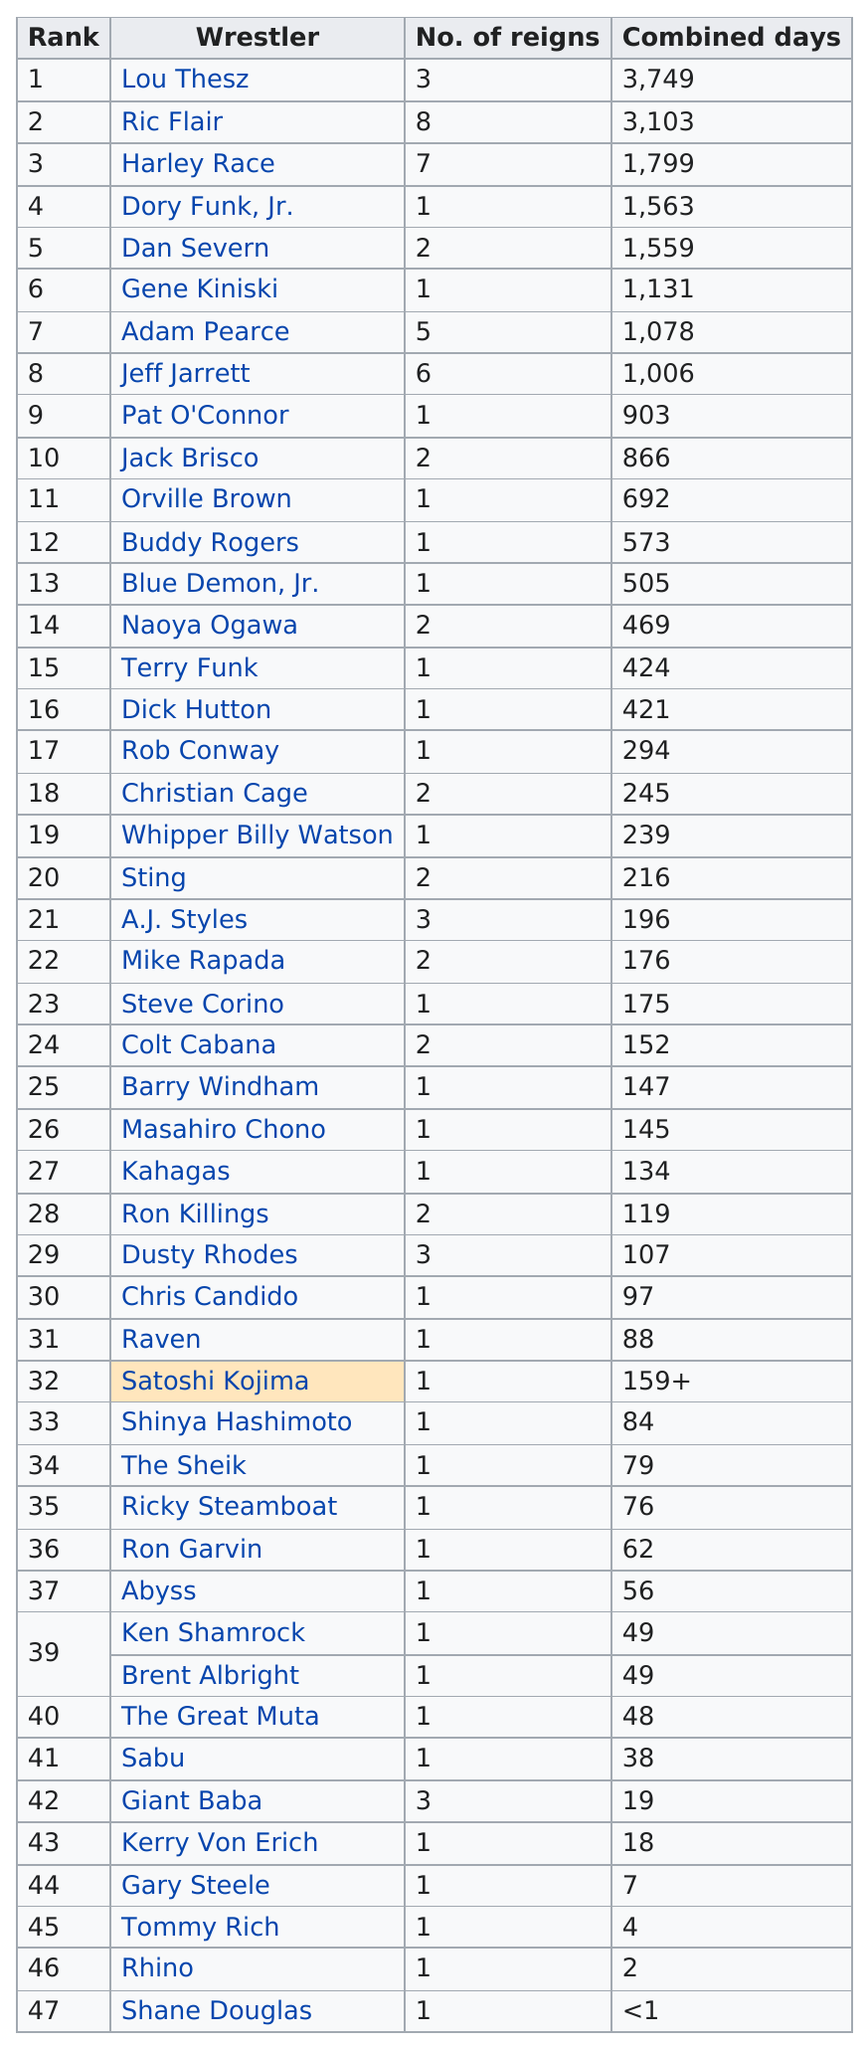Indicate a few pertinent items in this graphic. Ric Flair, who has held the title of NWA World Heavyweight Champion for a longer period of time than Gene Kiniski, is undoubtedly the champion with more experience and expertise in the ring. Ric Flair, a professional wrestler, holds the record for having the most number of reigns as NWA World Heavyweight Champion. Orville Brown held the NWA World Heavyweight Championship for a total of 692 days. 